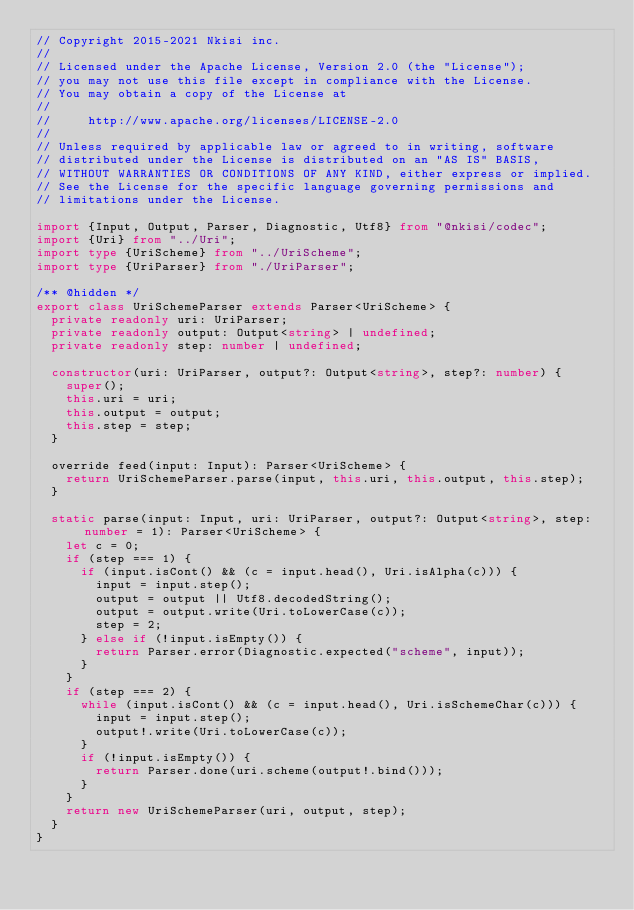Convert code to text. <code><loc_0><loc_0><loc_500><loc_500><_TypeScript_>// Copyright 2015-2021 Nkisi inc.
//
// Licensed under the Apache License, Version 2.0 (the "License");
// you may not use this file except in compliance with the License.
// You may obtain a copy of the License at
//
//     http://www.apache.org/licenses/LICENSE-2.0
//
// Unless required by applicable law or agreed to in writing, software
// distributed under the License is distributed on an "AS IS" BASIS,
// WITHOUT WARRANTIES OR CONDITIONS OF ANY KIND, either express or implied.
// See the License for the specific language governing permissions and
// limitations under the License.

import {Input, Output, Parser, Diagnostic, Utf8} from "@nkisi/codec";
import {Uri} from "../Uri";
import type {UriScheme} from "../UriScheme";
import type {UriParser} from "./UriParser";

/** @hidden */
export class UriSchemeParser extends Parser<UriScheme> {
  private readonly uri: UriParser;
  private readonly output: Output<string> | undefined;
  private readonly step: number | undefined;

  constructor(uri: UriParser, output?: Output<string>, step?: number) {
    super();
    this.uri = uri;
    this.output = output;
    this.step = step;
  }

  override feed(input: Input): Parser<UriScheme> {
    return UriSchemeParser.parse(input, this.uri, this.output, this.step);
  }

  static parse(input: Input, uri: UriParser, output?: Output<string>, step: number = 1): Parser<UriScheme> {
    let c = 0;
    if (step === 1) {
      if (input.isCont() && (c = input.head(), Uri.isAlpha(c))) {
        input = input.step();
        output = output || Utf8.decodedString();
        output = output.write(Uri.toLowerCase(c));
        step = 2;
      } else if (!input.isEmpty()) {
        return Parser.error(Diagnostic.expected("scheme", input));
      }
    }
    if (step === 2) {
      while (input.isCont() && (c = input.head(), Uri.isSchemeChar(c))) {
        input = input.step();
        output!.write(Uri.toLowerCase(c));
      }
      if (!input.isEmpty()) {
        return Parser.done(uri.scheme(output!.bind()));
      }
    }
    return new UriSchemeParser(uri, output, step);
  }
}
</code> 